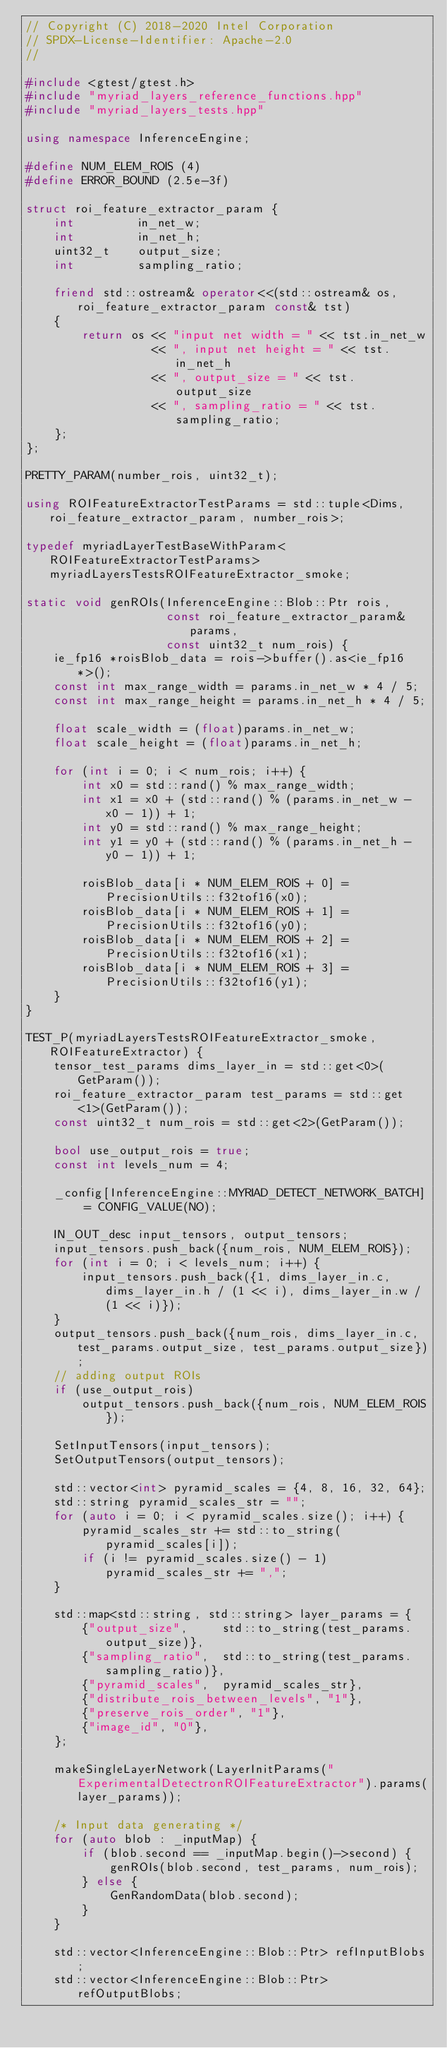Convert code to text. <code><loc_0><loc_0><loc_500><loc_500><_C++_>// Copyright (C) 2018-2020 Intel Corporation
// SPDX-License-Identifier: Apache-2.0
//

#include <gtest/gtest.h>
#include "myriad_layers_reference_functions.hpp"
#include "myriad_layers_tests.hpp"

using namespace InferenceEngine;

#define NUM_ELEM_ROIS (4)
#define ERROR_BOUND (2.5e-3f)

struct roi_feature_extractor_param {
    int         in_net_w;
    int         in_net_h;
    uint32_t    output_size;
    int         sampling_ratio;

    friend std::ostream& operator<<(std::ostream& os, roi_feature_extractor_param const& tst)
    {
        return os << "input net width = " << tst.in_net_w
                  << ", input net height = " << tst.in_net_h
                  << ", output_size = " << tst.output_size
                  << ", sampling_ratio = " << tst.sampling_ratio;
    };
};

PRETTY_PARAM(number_rois, uint32_t);

using ROIFeatureExtractorTestParams = std::tuple<Dims, roi_feature_extractor_param, number_rois>;

typedef myriadLayerTestBaseWithParam<ROIFeatureExtractorTestParams> myriadLayersTestsROIFeatureExtractor_smoke;

static void genROIs(InferenceEngine::Blob::Ptr rois,
                    const roi_feature_extractor_param& params,
                    const uint32_t num_rois) {
    ie_fp16 *roisBlob_data = rois->buffer().as<ie_fp16*>();
    const int max_range_width = params.in_net_w * 4 / 5;
    const int max_range_height = params.in_net_h * 4 / 5;

    float scale_width = (float)params.in_net_w;
    float scale_height = (float)params.in_net_h;

    for (int i = 0; i < num_rois; i++) {
        int x0 = std::rand() % max_range_width;
        int x1 = x0 + (std::rand() % (params.in_net_w - x0 - 1)) + 1;
        int y0 = std::rand() % max_range_height;
        int y1 = y0 + (std::rand() % (params.in_net_h - y0 - 1)) + 1;

        roisBlob_data[i * NUM_ELEM_ROIS + 0] = PrecisionUtils::f32tof16(x0);
        roisBlob_data[i * NUM_ELEM_ROIS + 1] = PrecisionUtils::f32tof16(y0);
        roisBlob_data[i * NUM_ELEM_ROIS + 2] = PrecisionUtils::f32tof16(x1);
        roisBlob_data[i * NUM_ELEM_ROIS + 3] = PrecisionUtils::f32tof16(y1);
    }
}

TEST_P(myriadLayersTestsROIFeatureExtractor_smoke, ROIFeatureExtractor) {
    tensor_test_params dims_layer_in = std::get<0>(GetParam());
    roi_feature_extractor_param test_params = std::get<1>(GetParam());
    const uint32_t num_rois = std::get<2>(GetParam());

    bool use_output_rois = true;
    const int levels_num = 4;

    _config[InferenceEngine::MYRIAD_DETECT_NETWORK_BATCH] = CONFIG_VALUE(NO);

    IN_OUT_desc input_tensors, output_tensors;
    input_tensors.push_back({num_rois, NUM_ELEM_ROIS});
    for (int i = 0; i < levels_num; i++) {
        input_tensors.push_back({1, dims_layer_in.c, dims_layer_in.h / (1 << i), dims_layer_in.w / (1 << i)});
    }
    output_tensors.push_back({num_rois, dims_layer_in.c, test_params.output_size, test_params.output_size});
    // adding output ROIs
    if (use_output_rois)
        output_tensors.push_back({num_rois, NUM_ELEM_ROIS});

    SetInputTensors(input_tensors);
    SetOutputTensors(output_tensors);

    std::vector<int> pyramid_scales = {4, 8, 16, 32, 64};
    std::string pyramid_scales_str = "";
    for (auto i = 0; i < pyramid_scales.size(); i++) {
        pyramid_scales_str += std::to_string(pyramid_scales[i]);
        if (i != pyramid_scales.size() - 1) pyramid_scales_str += ",";
    }

    std::map<std::string, std::string> layer_params = {
        {"output_size",     std::to_string(test_params.output_size)},
        {"sampling_ratio",  std::to_string(test_params.sampling_ratio)},
        {"pyramid_scales",  pyramid_scales_str},
        {"distribute_rois_between_levels", "1"},
        {"preserve_rois_order", "1"},
        {"image_id", "0"},
    };

    makeSingleLayerNetwork(LayerInitParams("ExperimentalDetectronROIFeatureExtractor").params(layer_params));

    /* Input data generating */
    for (auto blob : _inputMap) {
        if (blob.second == _inputMap.begin()->second) {
            genROIs(blob.second, test_params, num_rois);
        } else {
            GenRandomData(blob.second);
        }
    }

    std::vector<InferenceEngine::Blob::Ptr> refInputBlobs;
    std::vector<InferenceEngine::Blob::Ptr> refOutputBlobs;</code> 